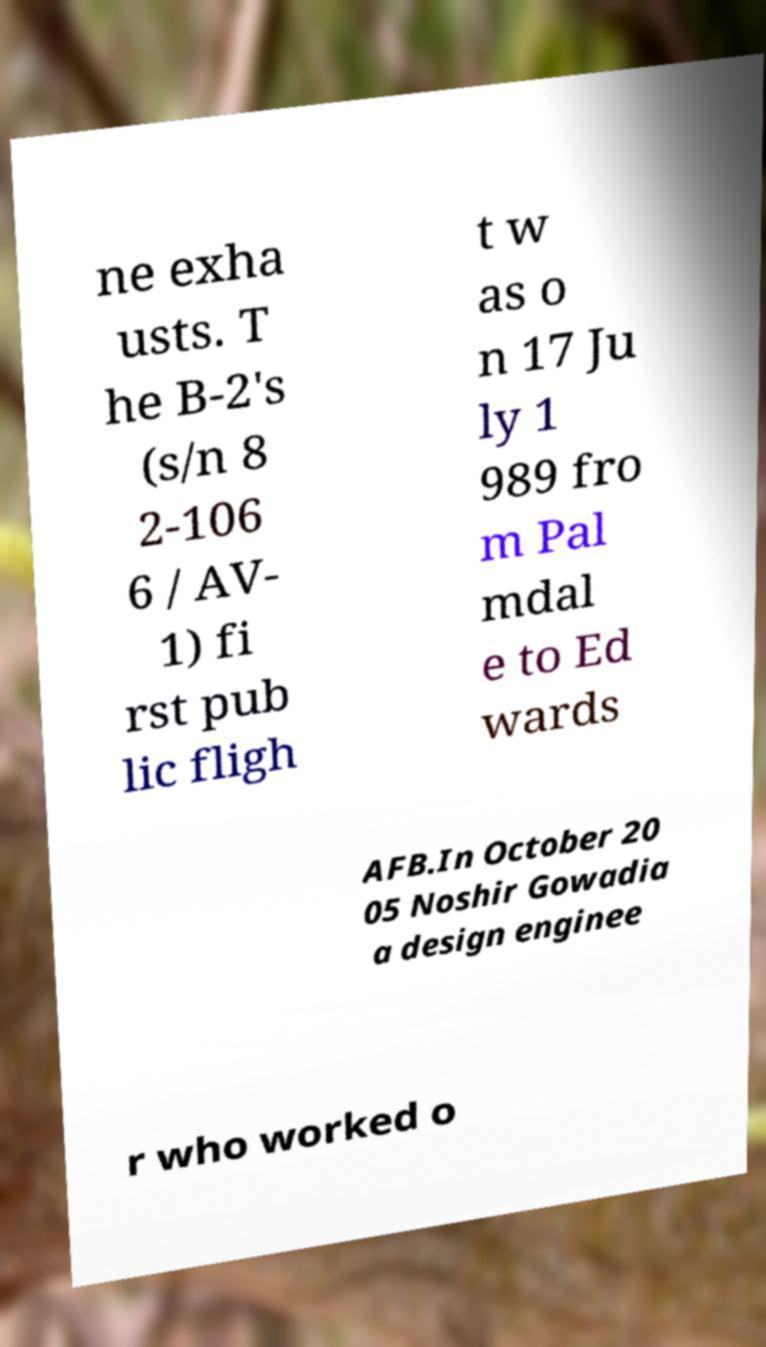Please identify and transcribe the text found in this image. ne exha usts. T he B-2's (s/n 8 2-106 6 / AV- 1) fi rst pub lic fligh t w as o n 17 Ju ly 1 989 fro m Pal mdal e to Ed wards AFB.In October 20 05 Noshir Gowadia a design enginee r who worked o 